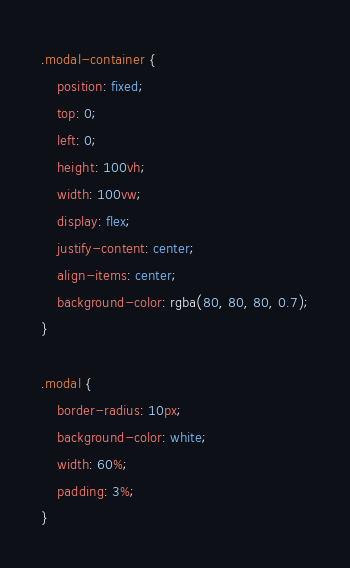<code> <loc_0><loc_0><loc_500><loc_500><_CSS_>.modal-container {
    position: fixed;
    top: 0;
    left: 0;
    height: 100vh;
    width: 100vw;
    display: flex;
    justify-content: center;
    align-items: center;
    background-color: rgba(80, 80, 80, 0.7);
}

.modal {
    border-radius: 10px;
    background-color: white;
    width: 60%;
    padding: 3%;
}</code> 